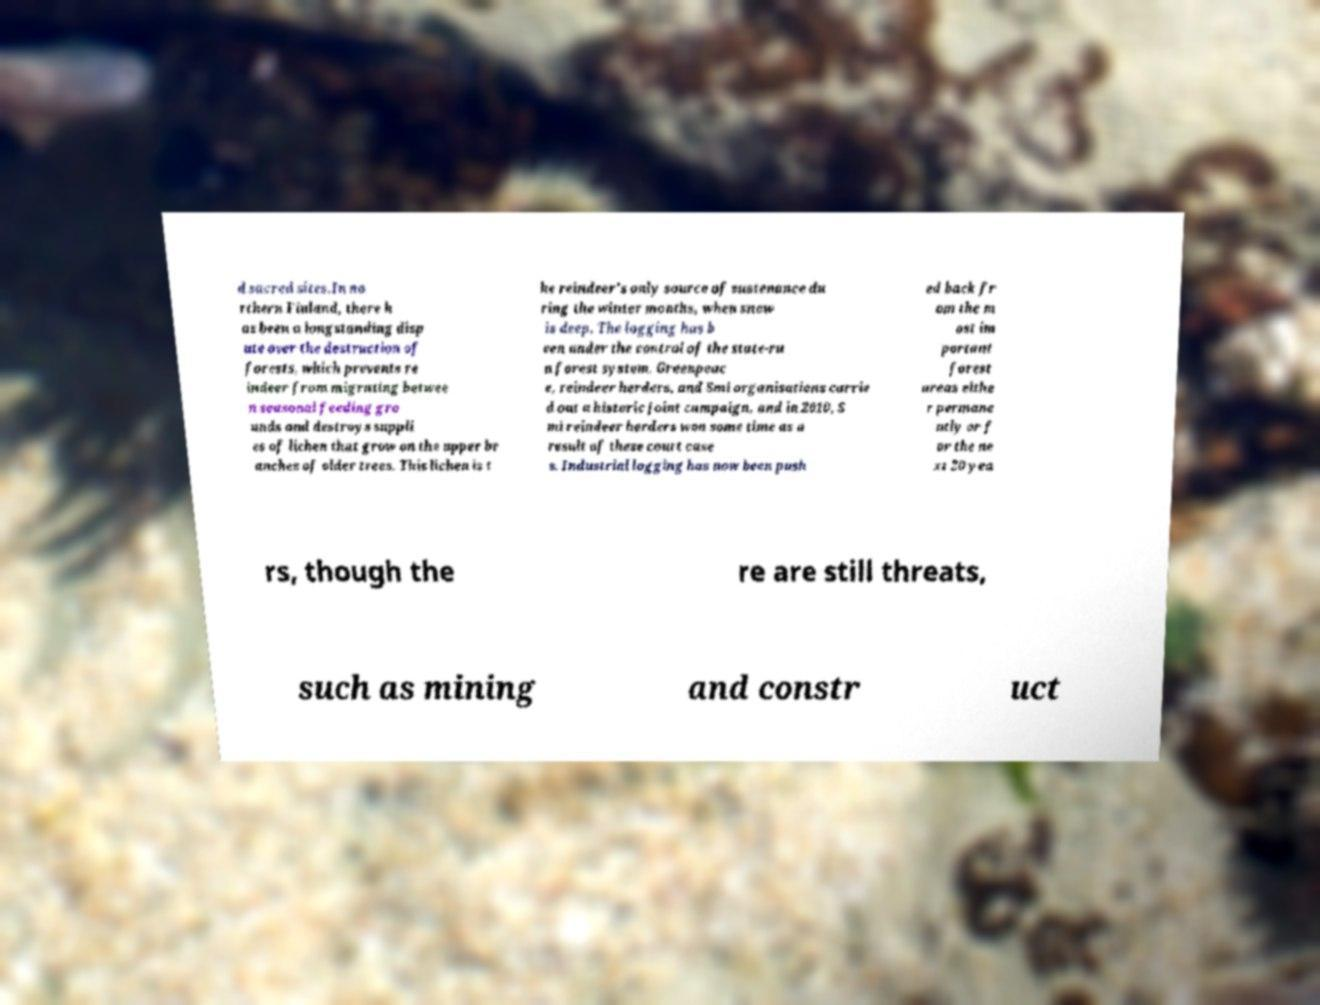There's text embedded in this image that I need extracted. Can you transcribe it verbatim? d sacred sites.In no rthern Finland, there h as been a longstanding disp ute over the destruction of forests, which prevents re indeer from migrating betwee n seasonal feeding gro unds and destroys suppli es of lichen that grow on the upper br anches of older trees. This lichen is t he reindeer's only source of sustenance du ring the winter months, when snow is deep. The logging has b een under the control of the state-ru n forest system. Greenpeac e, reindeer herders, and Smi organisations carrie d out a historic joint campaign, and in 2010, S mi reindeer herders won some time as a result of these court case s. Industrial logging has now been push ed back fr om the m ost im portant forest areas eithe r permane ntly or f or the ne xt 20 yea rs, though the re are still threats, such as mining and constr uct 